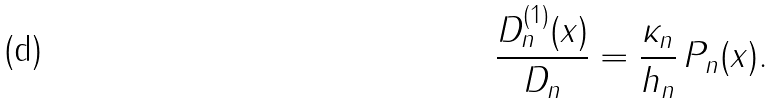<formula> <loc_0><loc_0><loc_500><loc_500>\frac { D _ { n } ^ { ( 1 ) } ( x ) } { D _ { n } } = \frac { \kappa _ { n } } { h _ { n } } \, P _ { n } ( x ) .</formula> 